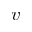<formula> <loc_0><loc_0><loc_500><loc_500>v</formula> 